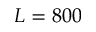Convert formula to latex. <formula><loc_0><loc_0><loc_500><loc_500>L = 8 0 0</formula> 